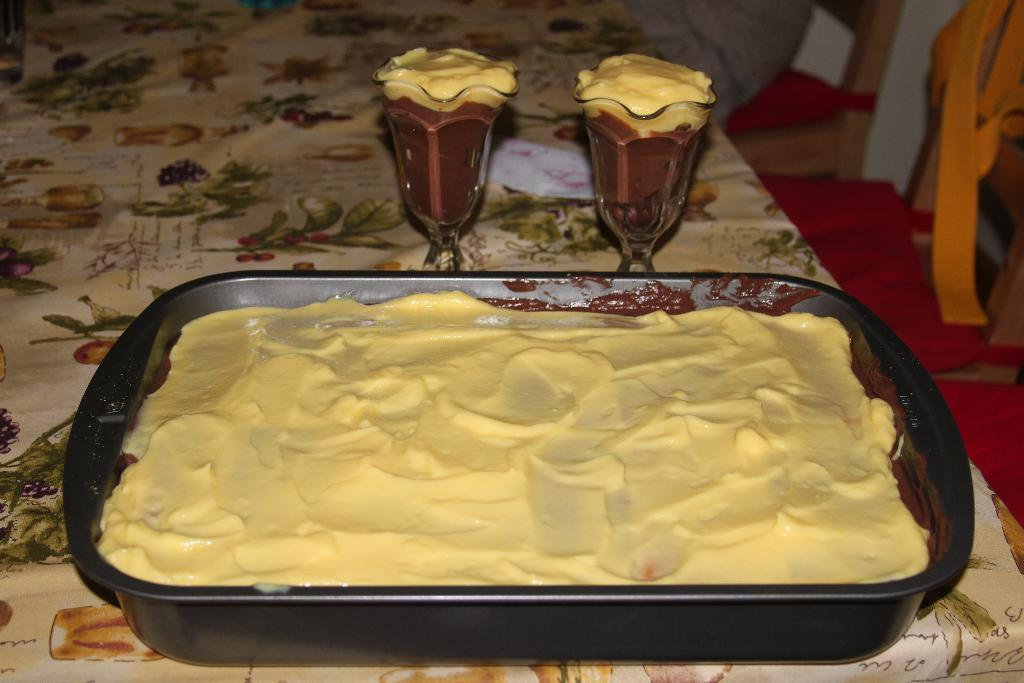What type of food item is in the tray in the image? The specific type of food item in the tray is not mentioned, but there is a food item in a tray in the image. What type of containers are the other food items in? The other food items are in glasses in the image. Where are the tray and glasses located? The tray and glasses are on a table in the image. What type of furniture is visible in the image? Chairs are visible in the image. What type of wave can be seen crashing on the shore in the image? There is no wave or shore visible in the image; it features a tray, glasses, a table, and chairs. 